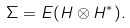Convert formula to latex. <formula><loc_0><loc_0><loc_500><loc_500>\Sigma = E ( H \otimes H ^ { * } ) .</formula> 